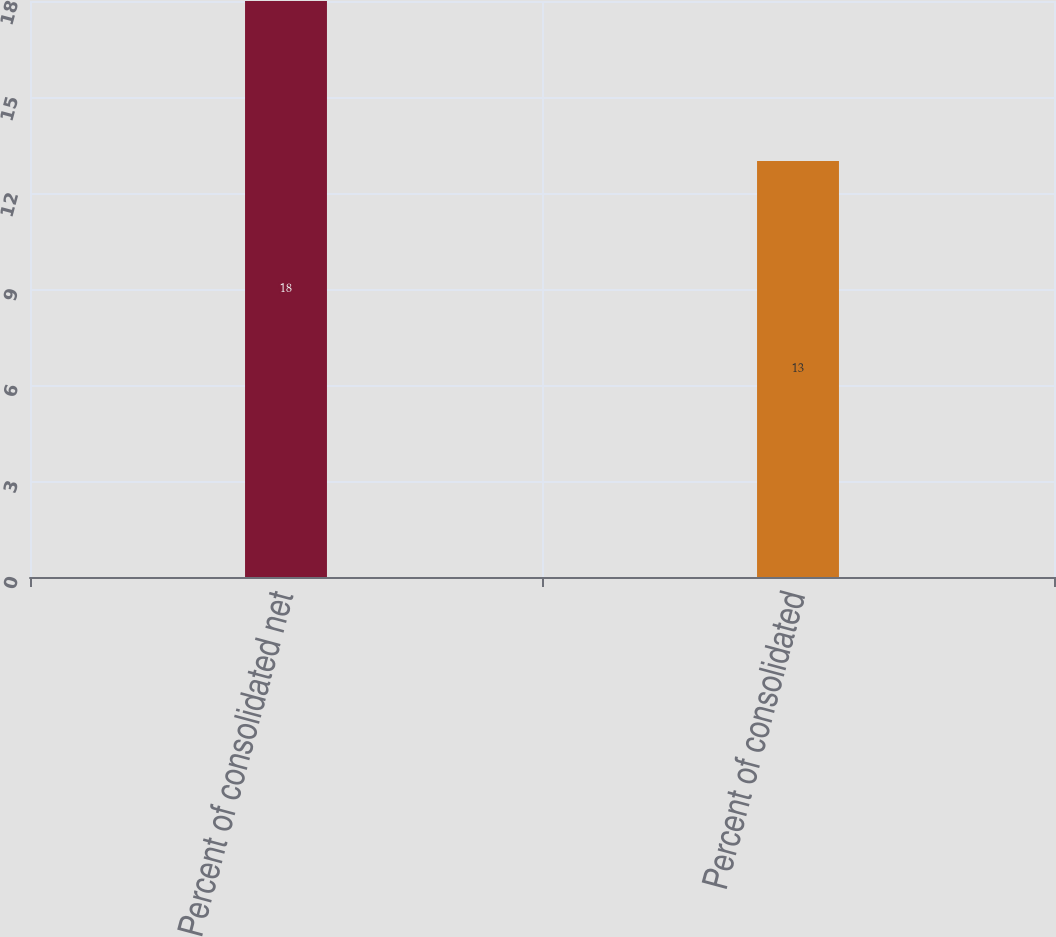<chart> <loc_0><loc_0><loc_500><loc_500><bar_chart><fcel>Percent of consolidated net<fcel>Percent of consolidated<nl><fcel>18<fcel>13<nl></chart> 